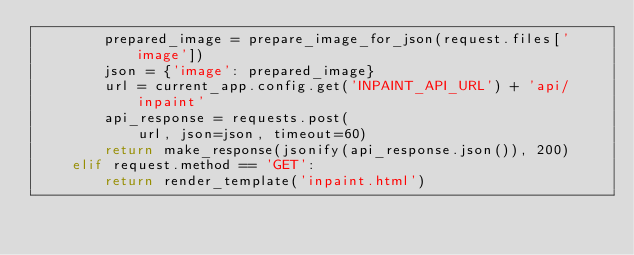<code> <loc_0><loc_0><loc_500><loc_500><_Python_>        prepared_image = prepare_image_for_json(request.files['image'])
        json = {'image': prepared_image}
        url = current_app.config.get('INPAINT_API_URL') + 'api/inpaint'
        api_response = requests.post(
            url, json=json, timeout=60)
        return make_response(jsonify(api_response.json()), 200)
    elif request.method == 'GET':
        return render_template('inpaint.html')

</code> 